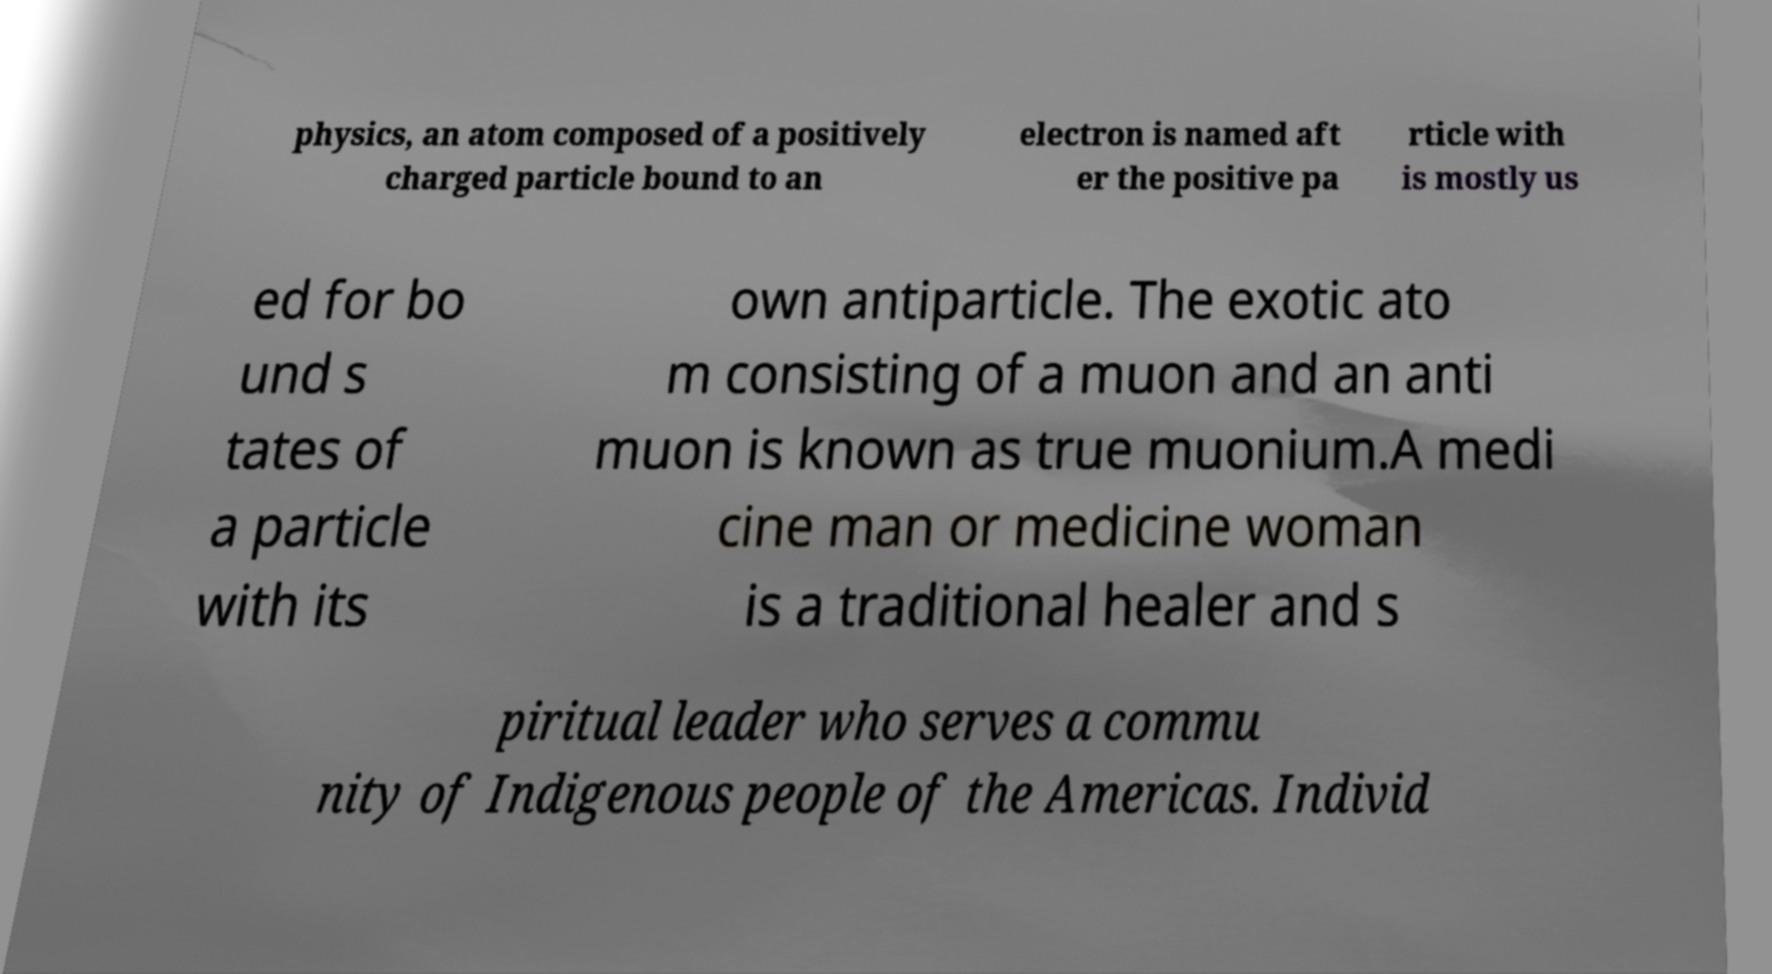Could you extract and type out the text from this image? physics, an atom composed of a positively charged particle bound to an electron is named aft er the positive pa rticle with is mostly us ed for bo und s tates of a particle with its own antiparticle. The exotic ato m consisting of a muon and an anti muon is known as true muonium.A medi cine man or medicine woman is a traditional healer and s piritual leader who serves a commu nity of Indigenous people of the Americas. Individ 